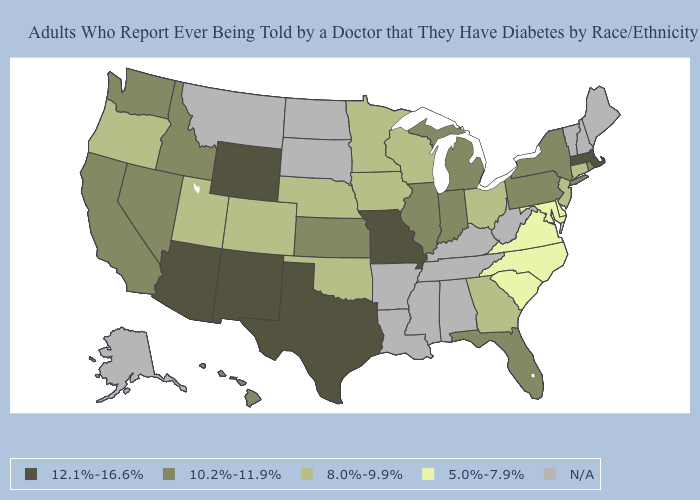Which states have the highest value in the USA?
Keep it brief. Arizona, Massachusetts, Missouri, New Mexico, Texas, Wyoming. Name the states that have a value in the range N/A?
Concise answer only. Alabama, Alaska, Arkansas, Kentucky, Louisiana, Maine, Mississippi, Montana, New Hampshire, North Dakota, South Dakota, Tennessee, Vermont, West Virginia. What is the value of Indiana?
Be succinct. 10.2%-11.9%. What is the value of Utah?
Give a very brief answer. 8.0%-9.9%. What is the highest value in the USA?
Give a very brief answer. 12.1%-16.6%. Which states have the lowest value in the USA?
Concise answer only. Delaware, Maryland, North Carolina, South Carolina, Virginia. What is the value of Texas?
Concise answer only. 12.1%-16.6%. What is the value of Alabama?
Keep it brief. N/A. What is the highest value in the USA?
Answer briefly. 12.1%-16.6%. What is the lowest value in the USA?
Short answer required. 5.0%-7.9%. What is the value of North Dakota?
Keep it brief. N/A. What is the highest value in states that border North Dakota?
Write a very short answer. 8.0%-9.9%. Among the states that border South Dakota , which have the lowest value?
Answer briefly. Iowa, Minnesota, Nebraska. Name the states that have a value in the range N/A?
Give a very brief answer. Alabama, Alaska, Arkansas, Kentucky, Louisiana, Maine, Mississippi, Montana, New Hampshire, North Dakota, South Dakota, Tennessee, Vermont, West Virginia. What is the lowest value in states that border Montana?
Write a very short answer. 10.2%-11.9%. 